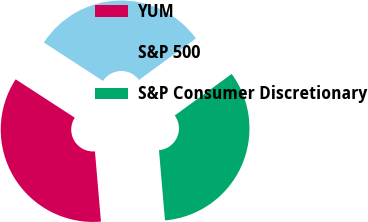Convert chart to OTSL. <chart><loc_0><loc_0><loc_500><loc_500><pie_chart><fcel>YUM<fcel>S&P 500<fcel>S&P Consumer Discretionary<nl><fcel>35.53%<fcel>30.79%<fcel>33.68%<nl></chart> 